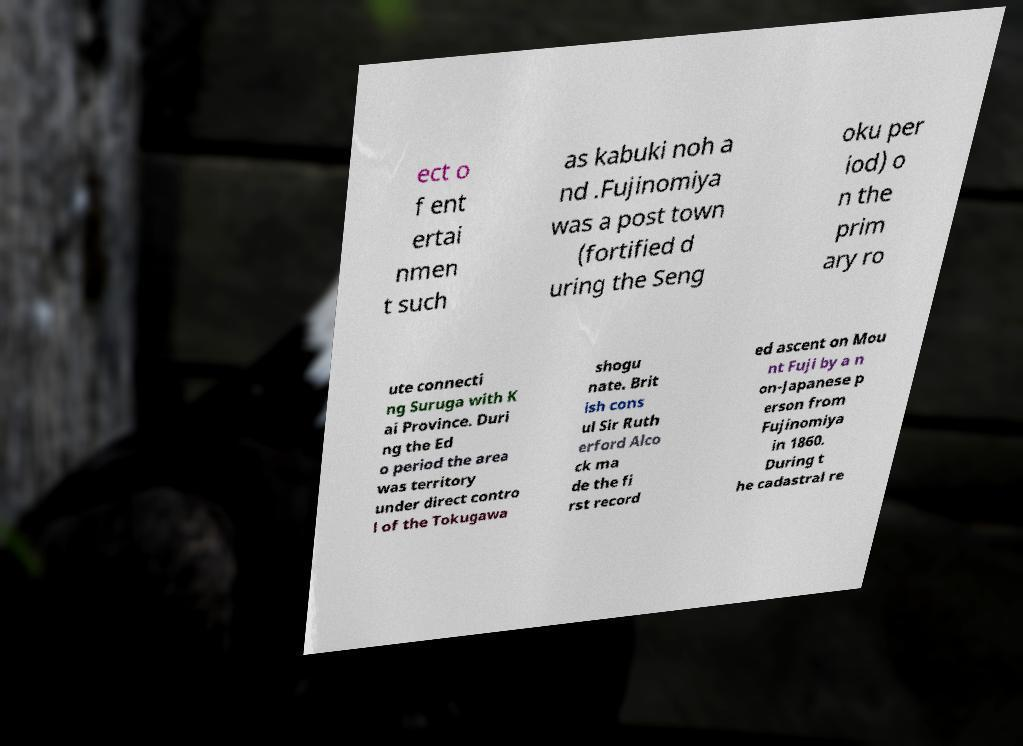For documentation purposes, I need the text within this image transcribed. Could you provide that? ect o f ent ertai nmen t such as kabuki noh a nd .Fujinomiya was a post town (fortified d uring the Seng oku per iod) o n the prim ary ro ute connecti ng Suruga with K ai Province. Duri ng the Ed o period the area was territory under direct contro l of the Tokugawa shogu nate. Brit ish cons ul Sir Ruth erford Alco ck ma de the fi rst record ed ascent on Mou nt Fuji by a n on-Japanese p erson from Fujinomiya in 1860. During t he cadastral re 